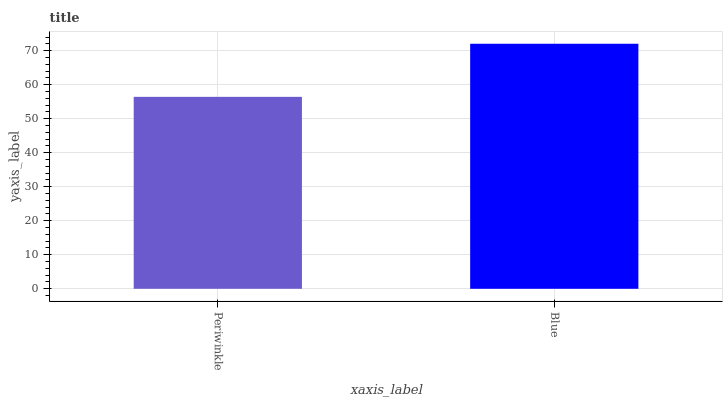Is Periwinkle the minimum?
Answer yes or no. Yes. Is Blue the maximum?
Answer yes or no. Yes. Is Blue the minimum?
Answer yes or no. No. Is Blue greater than Periwinkle?
Answer yes or no. Yes. Is Periwinkle less than Blue?
Answer yes or no. Yes. Is Periwinkle greater than Blue?
Answer yes or no. No. Is Blue less than Periwinkle?
Answer yes or no. No. Is Blue the high median?
Answer yes or no. Yes. Is Periwinkle the low median?
Answer yes or no. Yes. Is Periwinkle the high median?
Answer yes or no. No. Is Blue the low median?
Answer yes or no. No. 